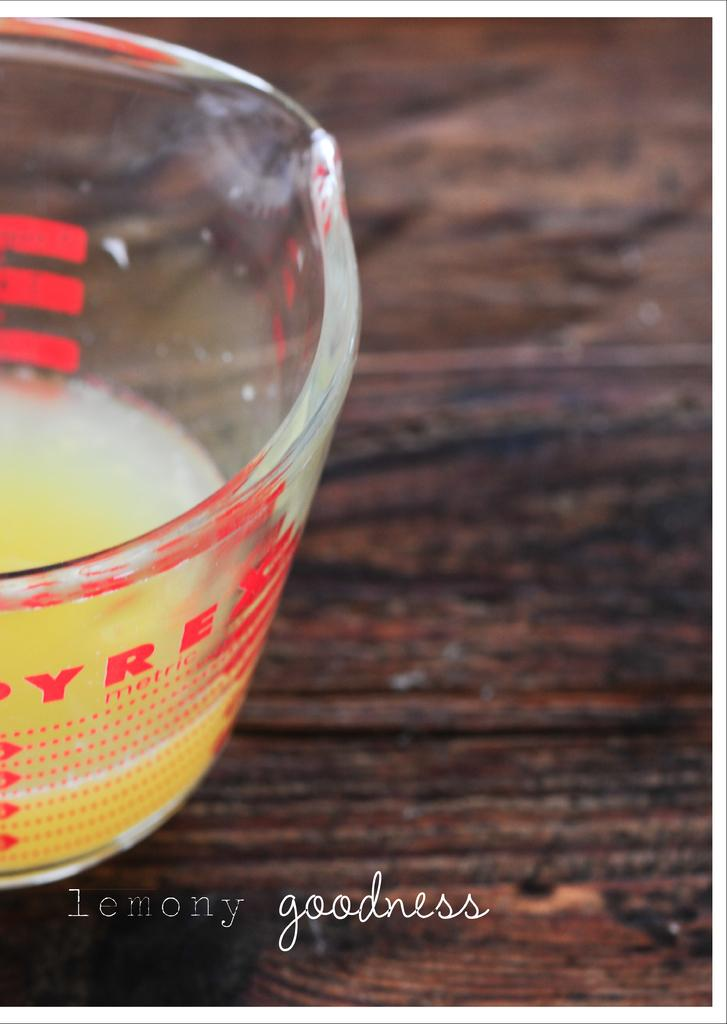What is in the glass that is visible in the image? There is a glass of juice in the image. Where is the glass of juice located? The glass of juice is present on a table. What idea does the mint plant in the image represent? There is no mint plant present in the image. 